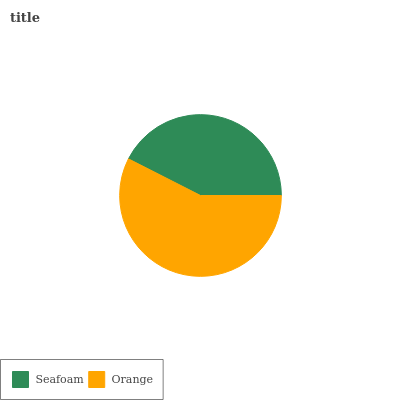Is Seafoam the minimum?
Answer yes or no. Yes. Is Orange the maximum?
Answer yes or no. Yes. Is Orange the minimum?
Answer yes or no. No. Is Orange greater than Seafoam?
Answer yes or no. Yes. Is Seafoam less than Orange?
Answer yes or no. Yes. Is Seafoam greater than Orange?
Answer yes or no. No. Is Orange less than Seafoam?
Answer yes or no. No. Is Orange the high median?
Answer yes or no. Yes. Is Seafoam the low median?
Answer yes or no. Yes. Is Seafoam the high median?
Answer yes or no. No. Is Orange the low median?
Answer yes or no. No. 